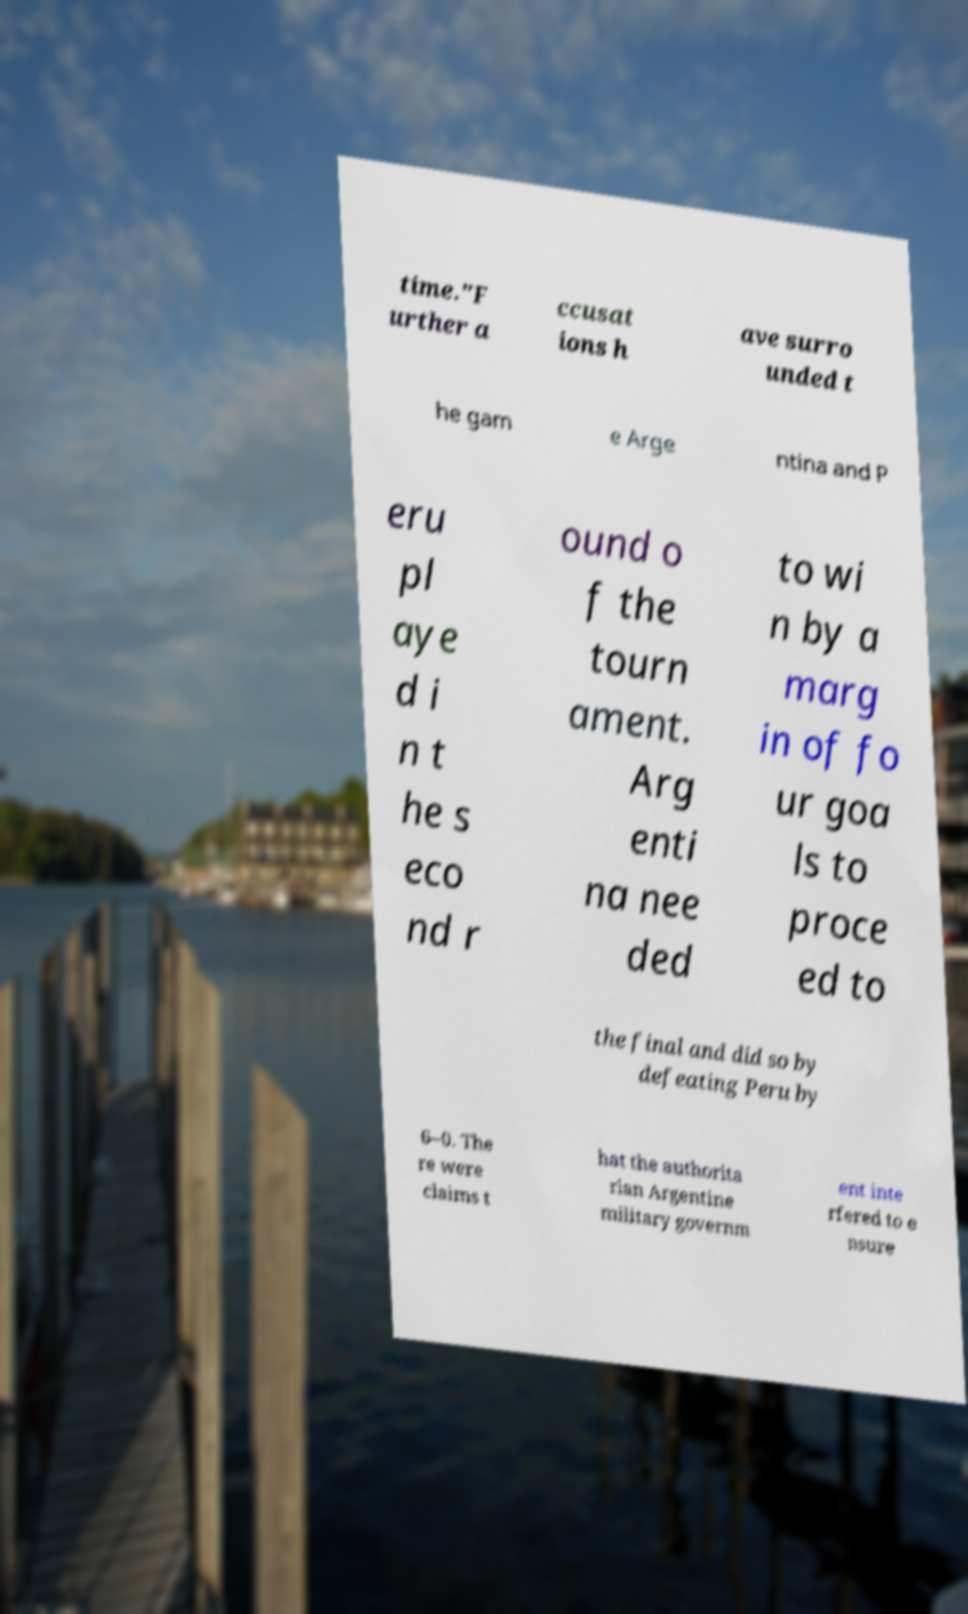Could you extract and type out the text from this image? time."F urther a ccusat ions h ave surro unded t he gam e Arge ntina and P eru pl aye d i n t he s eco nd r ound o f the tourn ament. Arg enti na nee ded to wi n by a marg in of fo ur goa ls to proce ed to the final and did so by defeating Peru by 6–0. The re were claims t hat the authorita rian Argentine military governm ent inte rfered to e nsure 